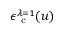Convert formula to latex. <formula><loc_0><loc_0><loc_500><loc_500>\epsilon _ { c } ^ { \lambda = 1 } ( u )</formula> 